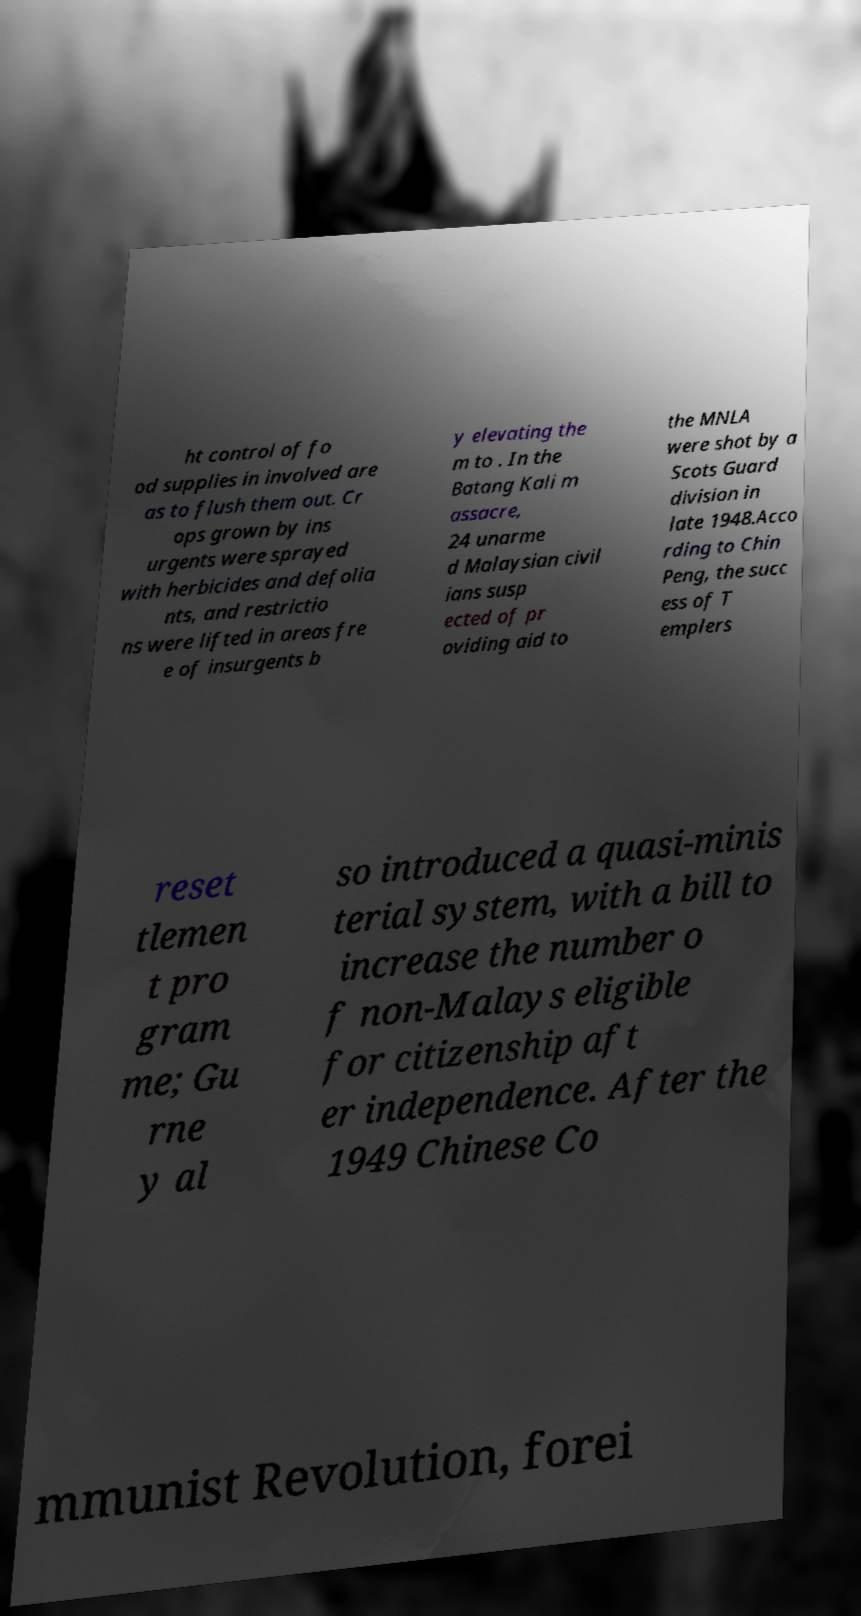Can you accurately transcribe the text from the provided image for me? ht control of fo od supplies in involved are as to flush them out. Cr ops grown by ins urgents were sprayed with herbicides and defolia nts, and restrictio ns were lifted in areas fre e of insurgents b y elevating the m to . In the Batang Kali m assacre, 24 unarme d Malaysian civil ians susp ected of pr oviding aid to the MNLA were shot by a Scots Guard division in late 1948.Acco rding to Chin Peng, the succ ess of T emplers reset tlemen t pro gram me; Gu rne y al so introduced a quasi-minis terial system, with a bill to increase the number o f non-Malays eligible for citizenship aft er independence. After the 1949 Chinese Co mmunist Revolution, forei 